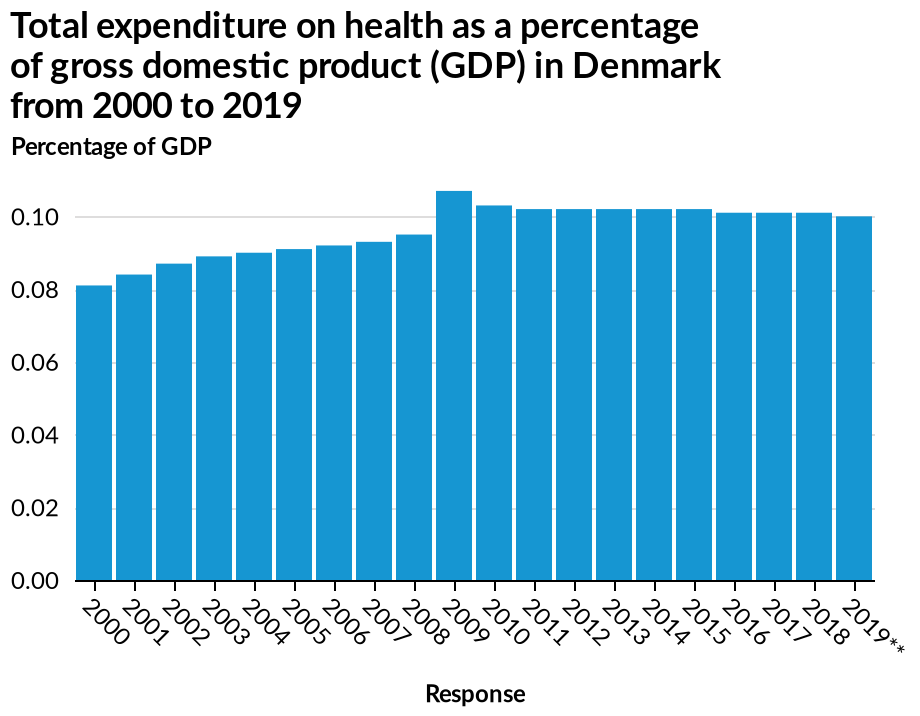<image>
What does the bar graph depict regarding Denmark's healthcare expenditure? The bar graph depicts the total expenditure on health as a percentage of GDP in Denmark from 2000 to 2019. Did the expenditure in 2010 surpass that of 2008? No, the expenditure in 2010 never went back to the figures of 2008. Did the expenditure in 2010 exceed the expenditure in 2009? Yes, there was a decrease in expenditure from 2009 to 2010. please summary the statistics and relations of the chart There was in increase in expenditure from 2009 however this did lower in 2010 but never went back to 2008 figures. 